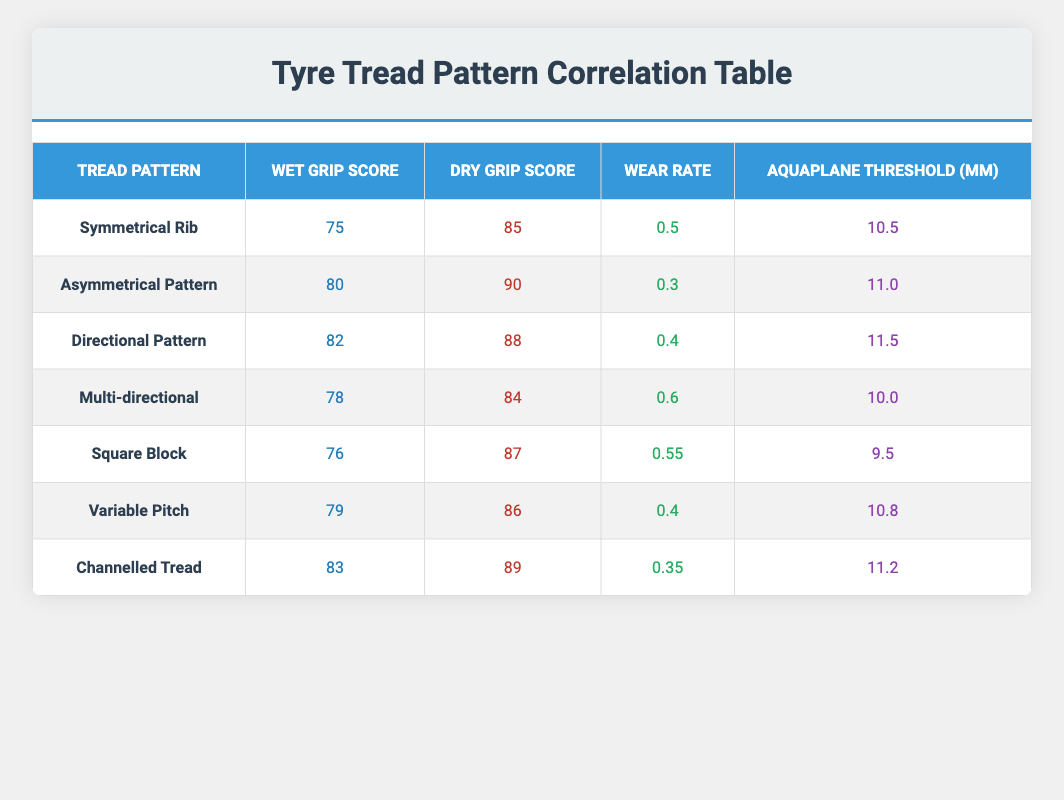What is the wet grip score of the Asymmetrical Pattern? Referring to the table, the wet grip score for the Asymmetrical Pattern is clearly listed.
Answer: 80 Which tread pattern has the best dry grip score? The table shows dry grip scores for all tread patterns. By comparing these scores, the Asymmetrical Pattern has the highest score at 90.
Answer: Asymmetrical Pattern What is the average wet grip score of all tread patterns? To find the average, sum the wet grip scores: 75 + 80 + 82 + 78 + 76 + 79 + 83 = 533. There are 7 tread patterns, so the average is 533 / 7 = 76.14.
Answer: 76.14 Is the wear rate of the Channelled Tread lower than that of the Symmetrical Rib? The table shows that the wear rate of the Channelled Tread is 0.35 while that of the Symmetrical Rib is 0.5. Since 0.35 is less than 0.5, the statement is true.
Answer: Yes What is the difference in wet grip score between the Directional Pattern and Multi-directional? The wet grip score for the Directional Pattern is 82, while for the Multi-directional, it is 78. The difference is 82 - 78 = 4.
Answer: 4 Which tread pattern has the lowest aquaplane threshold and what is that value? The table indicates the aquaplane thresholds for each tread pattern. The lowest value is found with the Square Block at 9.5 mm.
Answer: Square Block, 9.5 mm If we consider the average dry grip score of the patterns with a wet grip score above 80, what do we get? The patterns with a wet grip score above 80 are Asymmetrical Pattern (90), Directional Pattern (88), and Channelled Tread (89). Summing these gives 90 + 88 + 89 = 267. The average is 267 / 3 = 89.
Answer: 89 Does the tread pattern with the highest wet grip score also have the highest dry grip score? The tread pattern with the highest wet grip score is the Channelled Tread with a score of 83 but the highest dry grip score belongs to the Asymmetrical Pattern at 90. Thus, the statement is false.
Answer: No Which tread patterns have a wear rate of equal to or lower than 0.4? Referring to the table, the tread patterns with a wear rate of 0.4 or less are the Asymmetrical Pattern (0.3), Channelled Tread (0.35), and Variable Pitch (0.4).
Answer: Asymmetrical Pattern, Channelled Tread, Variable Pitch 